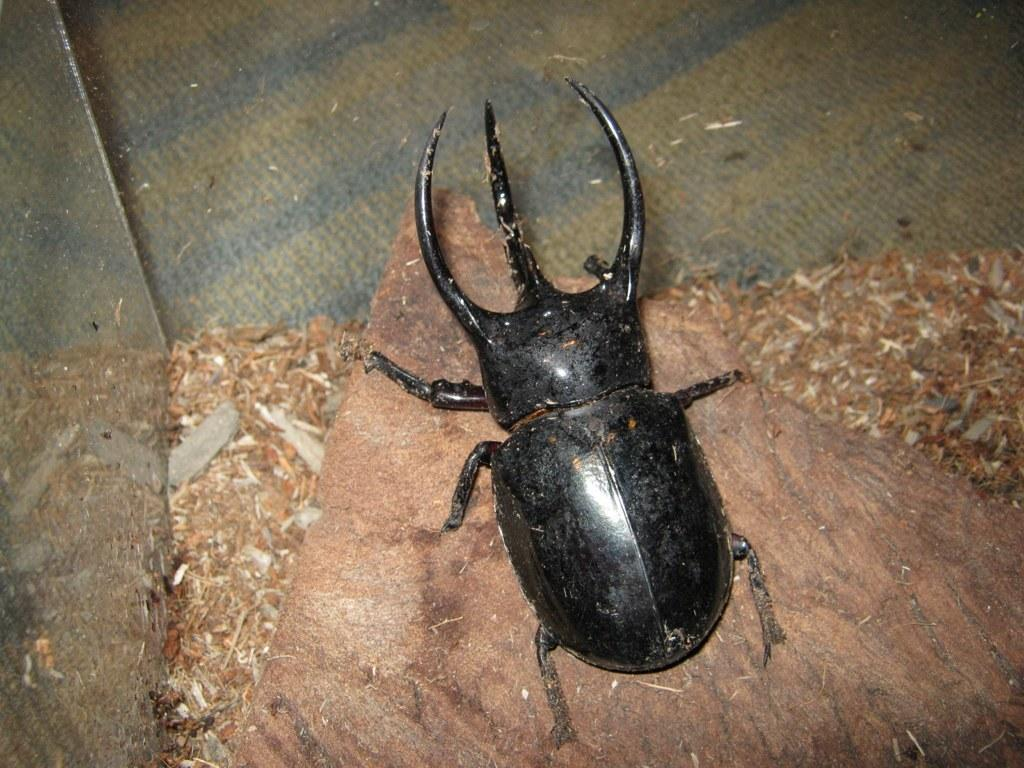What type of creature can be seen in the image? There is an insect in the image. What is present around the insect in the image? There is waste visible around the insect in the image. What type of stone can be seen in the middle of the image? There is no stone present in the image. What type of leather object is visible near the insect in the image? There is no leather object present in the image. 